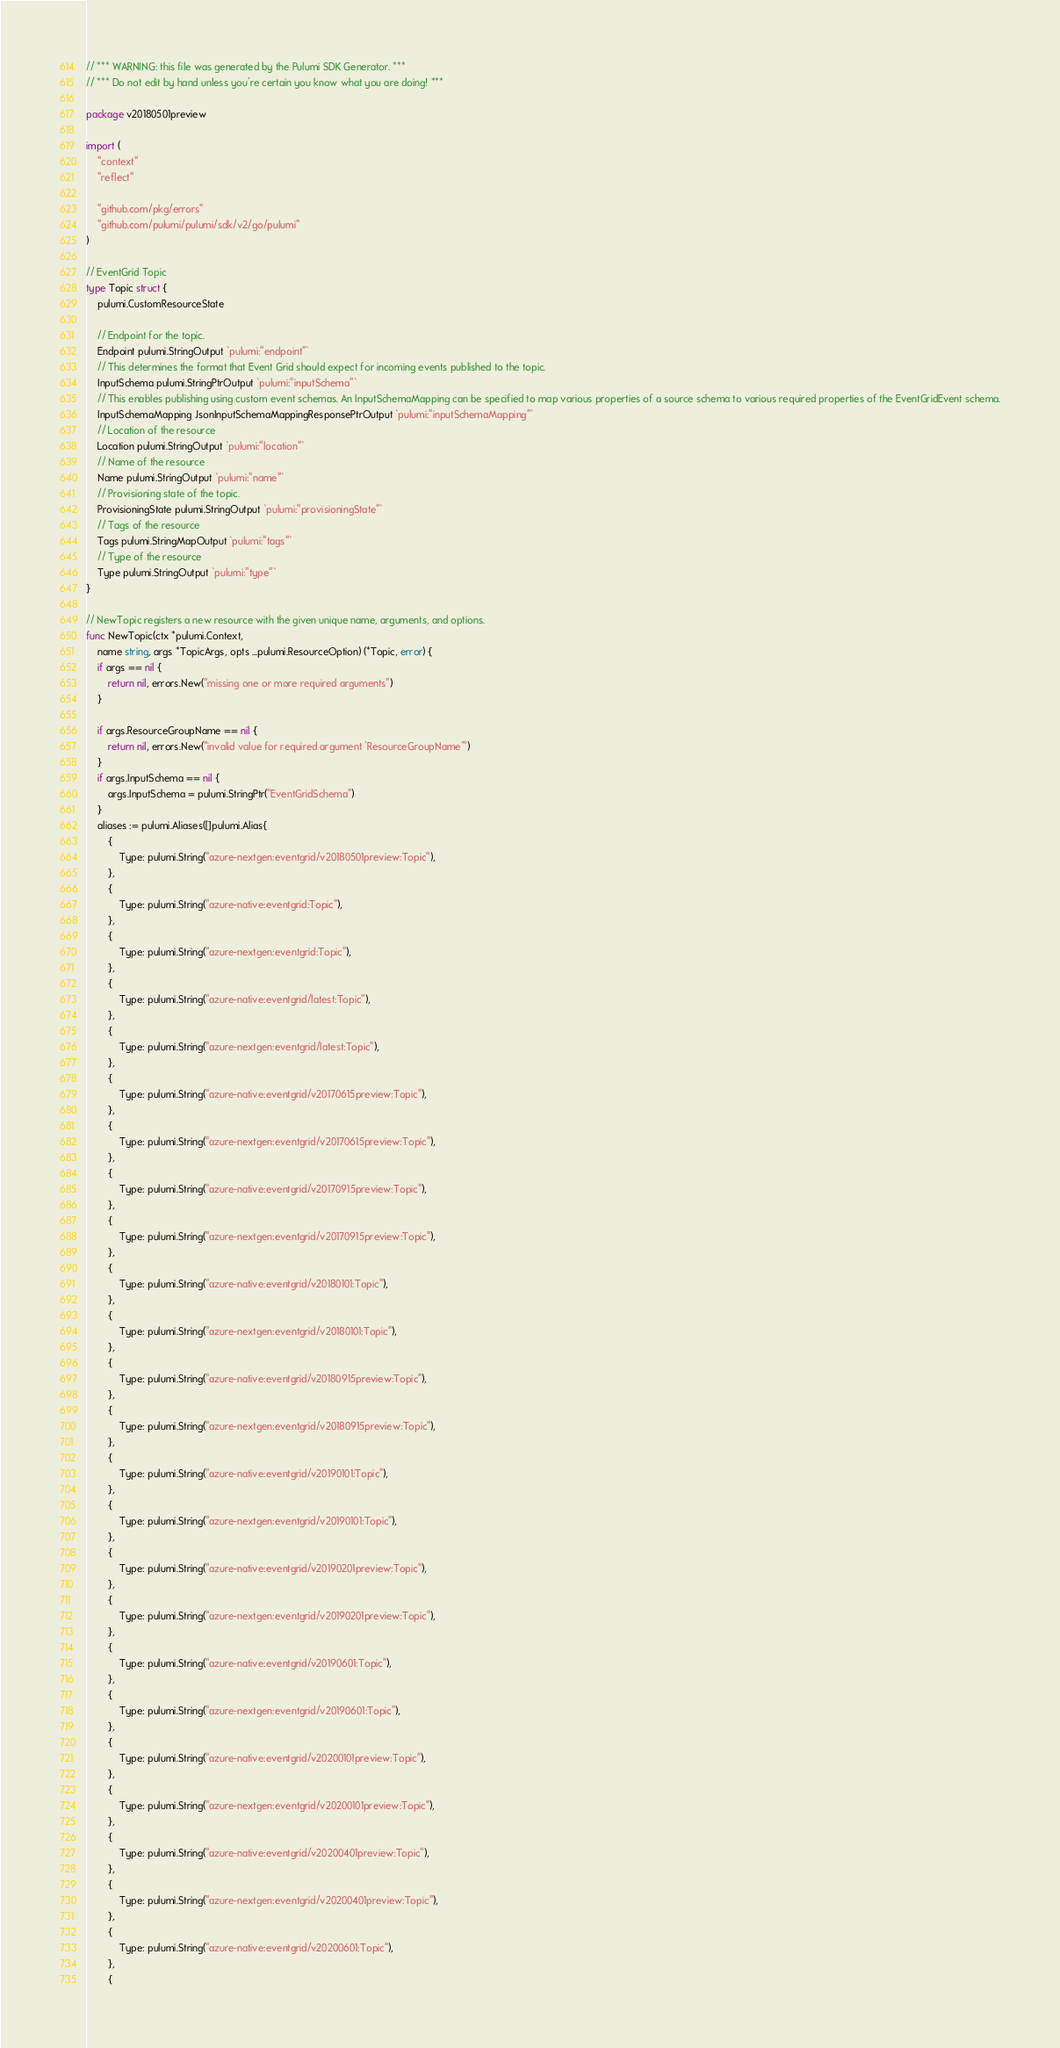Convert code to text. <code><loc_0><loc_0><loc_500><loc_500><_Go_>// *** WARNING: this file was generated by the Pulumi SDK Generator. ***
// *** Do not edit by hand unless you're certain you know what you are doing! ***

package v20180501preview

import (
	"context"
	"reflect"

	"github.com/pkg/errors"
	"github.com/pulumi/pulumi/sdk/v2/go/pulumi"
)

// EventGrid Topic
type Topic struct {
	pulumi.CustomResourceState

	// Endpoint for the topic.
	Endpoint pulumi.StringOutput `pulumi:"endpoint"`
	// This determines the format that Event Grid should expect for incoming events published to the topic.
	InputSchema pulumi.StringPtrOutput `pulumi:"inputSchema"`
	// This enables publishing using custom event schemas. An InputSchemaMapping can be specified to map various properties of a source schema to various required properties of the EventGridEvent schema.
	InputSchemaMapping JsonInputSchemaMappingResponsePtrOutput `pulumi:"inputSchemaMapping"`
	// Location of the resource
	Location pulumi.StringOutput `pulumi:"location"`
	// Name of the resource
	Name pulumi.StringOutput `pulumi:"name"`
	// Provisioning state of the topic.
	ProvisioningState pulumi.StringOutput `pulumi:"provisioningState"`
	// Tags of the resource
	Tags pulumi.StringMapOutput `pulumi:"tags"`
	// Type of the resource
	Type pulumi.StringOutput `pulumi:"type"`
}

// NewTopic registers a new resource with the given unique name, arguments, and options.
func NewTopic(ctx *pulumi.Context,
	name string, args *TopicArgs, opts ...pulumi.ResourceOption) (*Topic, error) {
	if args == nil {
		return nil, errors.New("missing one or more required arguments")
	}

	if args.ResourceGroupName == nil {
		return nil, errors.New("invalid value for required argument 'ResourceGroupName'")
	}
	if args.InputSchema == nil {
		args.InputSchema = pulumi.StringPtr("EventGridSchema")
	}
	aliases := pulumi.Aliases([]pulumi.Alias{
		{
			Type: pulumi.String("azure-nextgen:eventgrid/v20180501preview:Topic"),
		},
		{
			Type: pulumi.String("azure-native:eventgrid:Topic"),
		},
		{
			Type: pulumi.String("azure-nextgen:eventgrid:Topic"),
		},
		{
			Type: pulumi.String("azure-native:eventgrid/latest:Topic"),
		},
		{
			Type: pulumi.String("azure-nextgen:eventgrid/latest:Topic"),
		},
		{
			Type: pulumi.String("azure-native:eventgrid/v20170615preview:Topic"),
		},
		{
			Type: pulumi.String("azure-nextgen:eventgrid/v20170615preview:Topic"),
		},
		{
			Type: pulumi.String("azure-native:eventgrid/v20170915preview:Topic"),
		},
		{
			Type: pulumi.String("azure-nextgen:eventgrid/v20170915preview:Topic"),
		},
		{
			Type: pulumi.String("azure-native:eventgrid/v20180101:Topic"),
		},
		{
			Type: pulumi.String("azure-nextgen:eventgrid/v20180101:Topic"),
		},
		{
			Type: pulumi.String("azure-native:eventgrid/v20180915preview:Topic"),
		},
		{
			Type: pulumi.String("azure-nextgen:eventgrid/v20180915preview:Topic"),
		},
		{
			Type: pulumi.String("azure-native:eventgrid/v20190101:Topic"),
		},
		{
			Type: pulumi.String("azure-nextgen:eventgrid/v20190101:Topic"),
		},
		{
			Type: pulumi.String("azure-native:eventgrid/v20190201preview:Topic"),
		},
		{
			Type: pulumi.String("azure-nextgen:eventgrid/v20190201preview:Topic"),
		},
		{
			Type: pulumi.String("azure-native:eventgrid/v20190601:Topic"),
		},
		{
			Type: pulumi.String("azure-nextgen:eventgrid/v20190601:Topic"),
		},
		{
			Type: pulumi.String("azure-native:eventgrid/v20200101preview:Topic"),
		},
		{
			Type: pulumi.String("azure-nextgen:eventgrid/v20200101preview:Topic"),
		},
		{
			Type: pulumi.String("azure-native:eventgrid/v20200401preview:Topic"),
		},
		{
			Type: pulumi.String("azure-nextgen:eventgrid/v20200401preview:Topic"),
		},
		{
			Type: pulumi.String("azure-native:eventgrid/v20200601:Topic"),
		},
		{</code> 